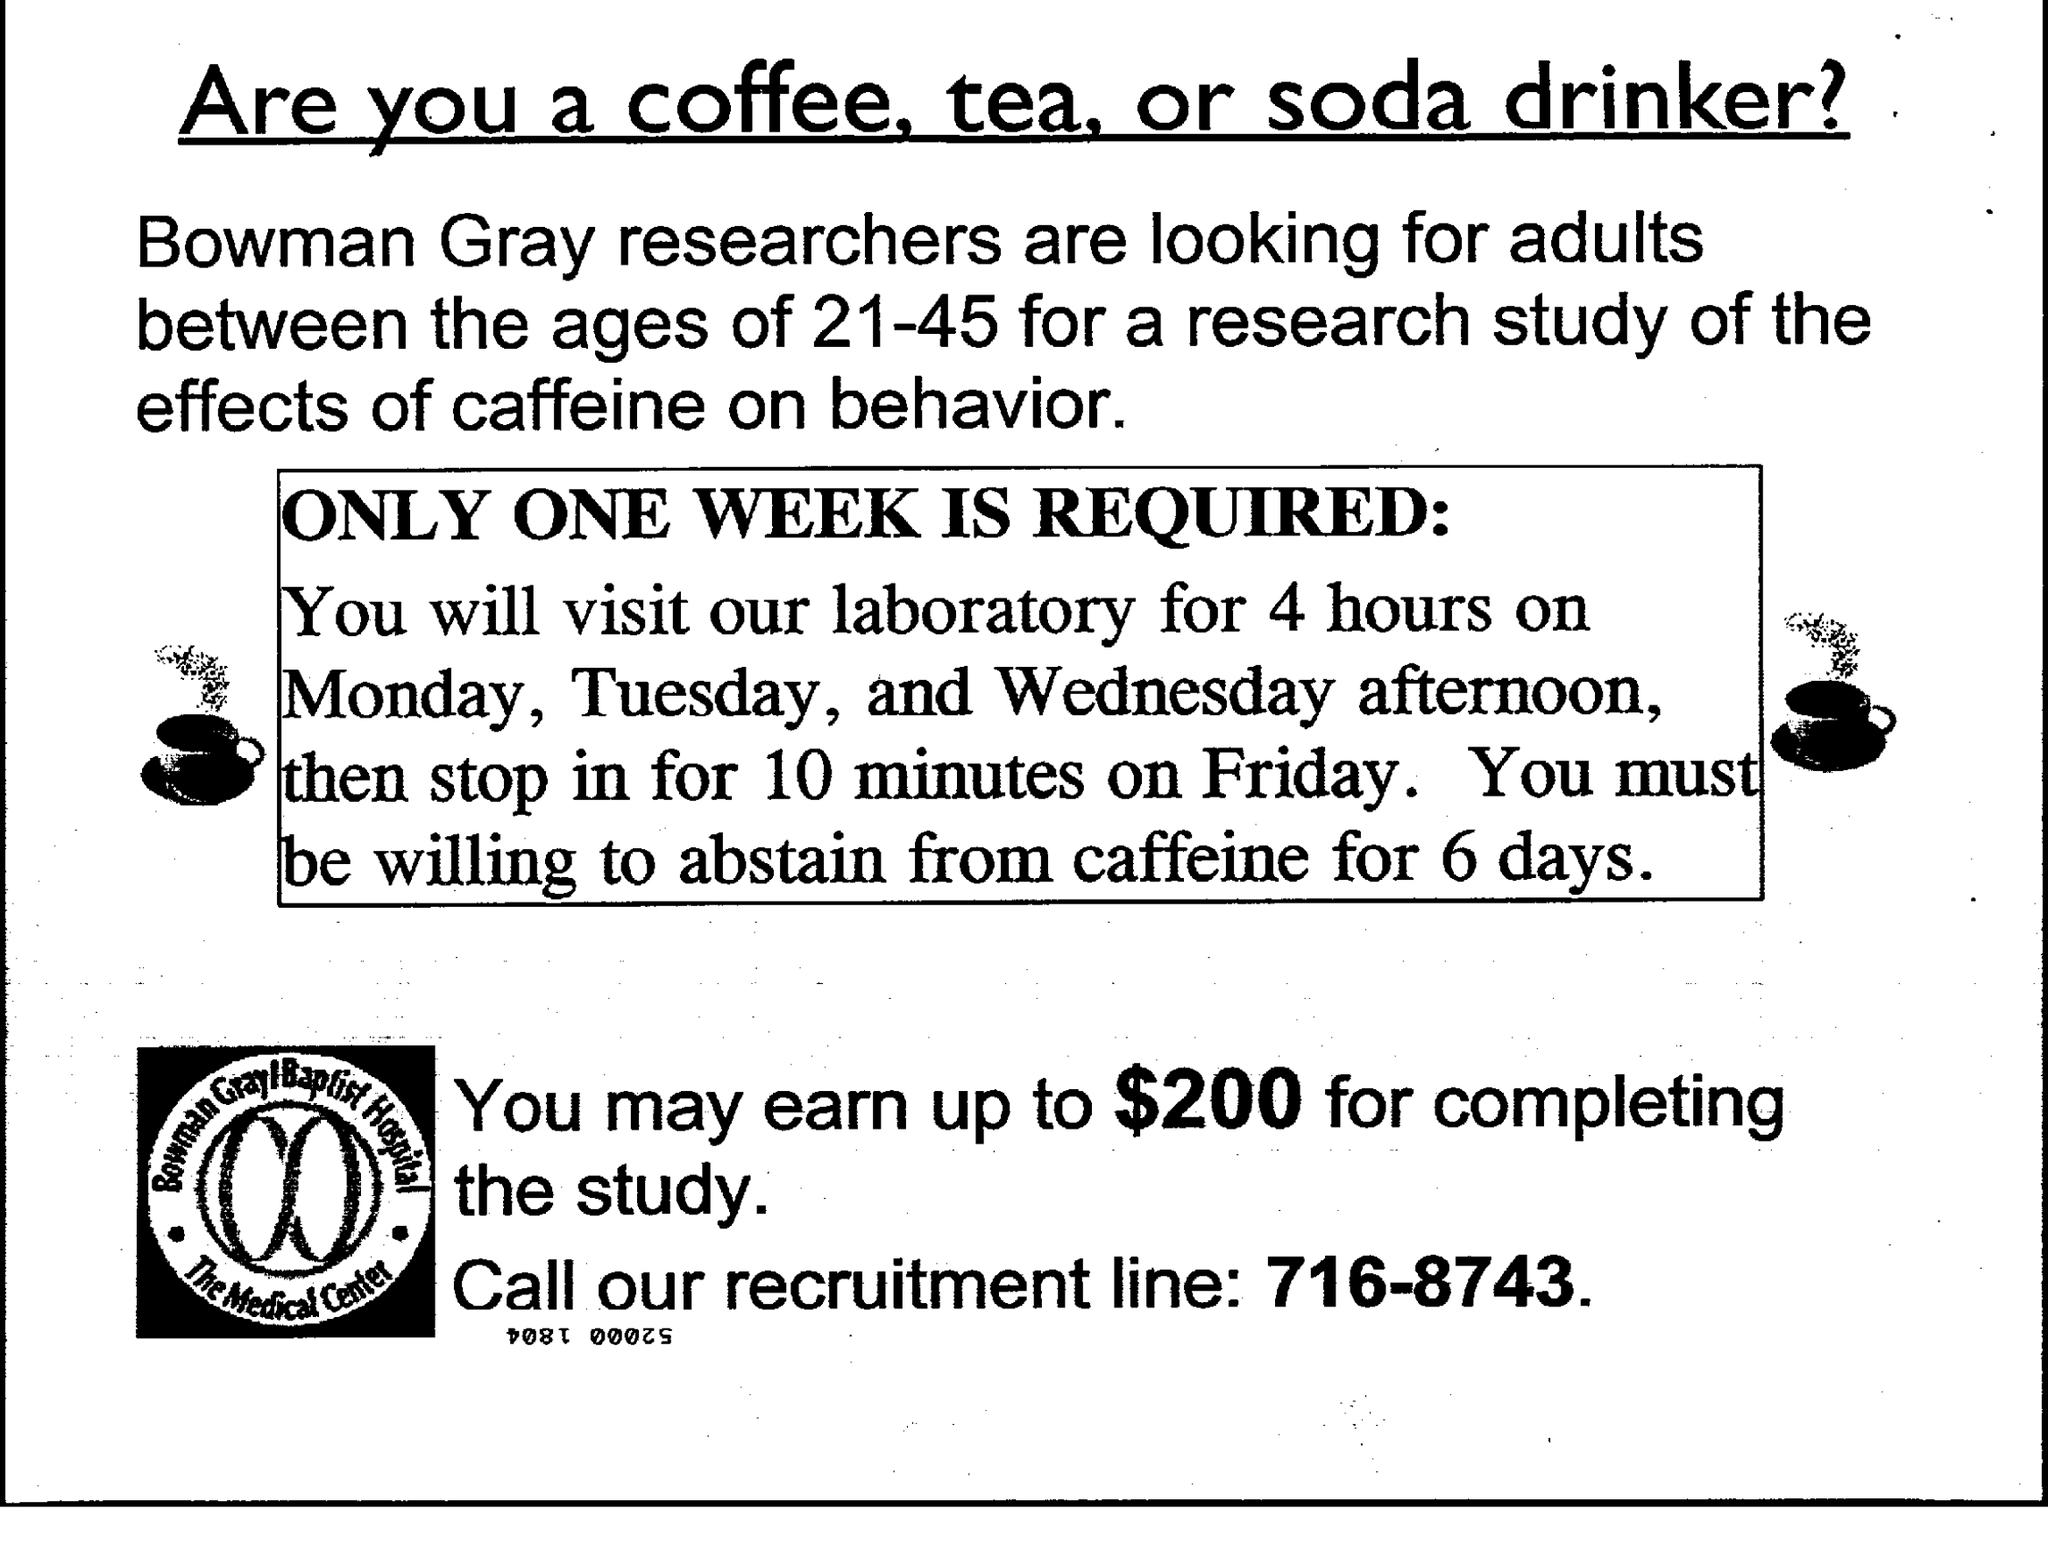What is the document title?
Provide a succinct answer. Are you a coffee, tea or soda drinker ?. What is the age group the researchers are looking for?
Give a very brief answer. 21-45. For how many hours should you visit the laboratory from Monday to Wednesday?
Ensure brevity in your answer.  4 hours. For how many days should you abstain from caffeine?
Make the answer very short. 6 days. Upto how much can you earn for completing the study?
Your response must be concise. $200. What is the recruitment line number given?
Your response must be concise. 716-8743. 